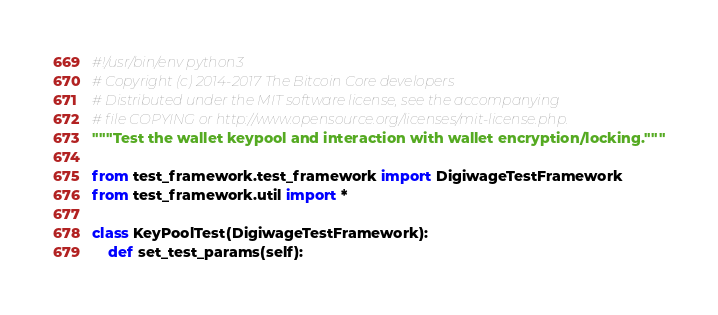Convert code to text. <code><loc_0><loc_0><loc_500><loc_500><_Python_>#!/usr/bin/env python3
# Copyright (c) 2014-2017 The Bitcoin Core developers
# Distributed under the MIT software license, see the accompanying
# file COPYING or http://www.opensource.org/licenses/mit-license.php.
"""Test the wallet keypool and interaction with wallet encryption/locking."""

from test_framework.test_framework import DigiwageTestFramework
from test_framework.util import *

class KeyPoolTest(DigiwageTestFramework):
    def set_test_params(self):</code> 